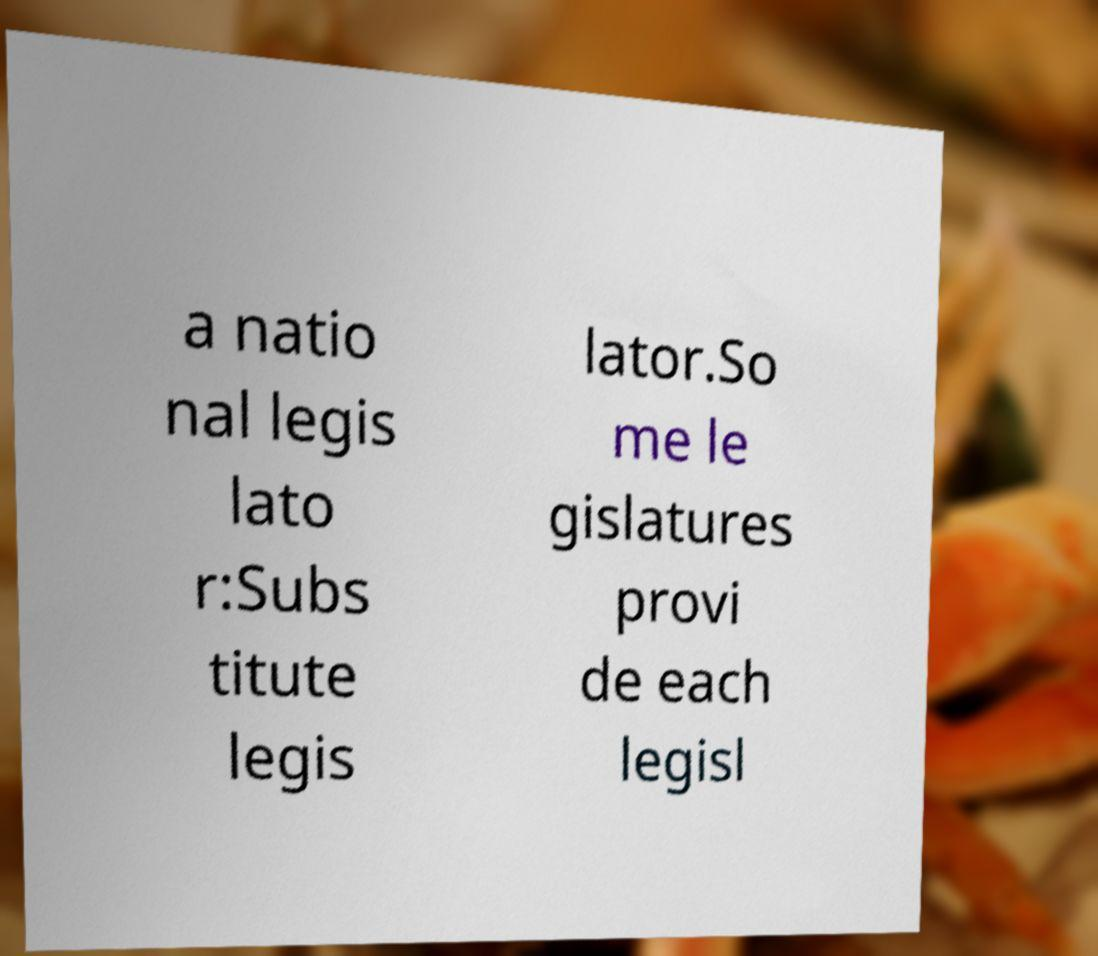For documentation purposes, I need the text within this image transcribed. Could you provide that? a natio nal legis lato r:Subs titute legis lator.So me le gislatures provi de each legisl 